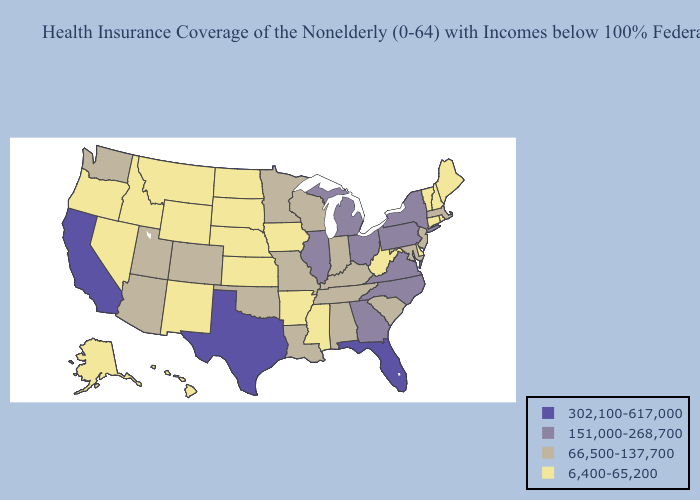What is the value of Illinois?
Be succinct. 151,000-268,700. What is the lowest value in the USA?
Be succinct. 6,400-65,200. Name the states that have a value in the range 302,100-617,000?
Short answer required. California, Florida, Texas. Name the states that have a value in the range 66,500-137,700?
Keep it brief. Alabama, Arizona, Colorado, Indiana, Kentucky, Louisiana, Maryland, Massachusetts, Minnesota, Missouri, New Jersey, Oklahoma, South Carolina, Tennessee, Utah, Washington, Wisconsin. Name the states that have a value in the range 151,000-268,700?
Answer briefly. Georgia, Illinois, Michigan, New York, North Carolina, Ohio, Pennsylvania, Virginia. What is the value of Idaho?
Short answer required. 6,400-65,200. Does Iowa have the highest value in the MidWest?
Answer briefly. No. What is the value of Oregon?
Keep it brief. 6,400-65,200. Which states hav the highest value in the South?
Quick response, please. Florida, Texas. How many symbols are there in the legend?
Be succinct. 4. Name the states that have a value in the range 151,000-268,700?
Be succinct. Georgia, Illinois, Michigan, New York, North Carolina, Ohio, Pennsylvania, Virginia. Name the states that have a value in the range 302,100-617,000?
Keep it brief. California, Florida, Texas. Does Wisconsin have the lowest value in the USA?
Keep it brief. No. Name the states that have a value in the range 151,000-268,700?
Keep it brief. Georgia, Illinois, Michigan, New York, North Carolina, Ohio, Pennsylvania, Virginia. 